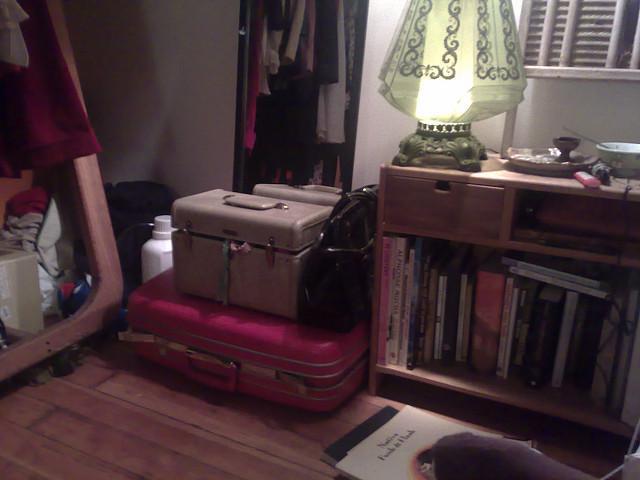How many colors are the three pieces of luggage?
Give a very brief answer. 3. How many suitcases are there?
Give a very brief answer. 2. How many books are there?
Give a very brief answer. 3. How many giraffes are pictured?
Give a very brief answer. 0. 